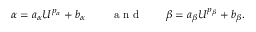Convert formula to latex. <formula><loc_0><loc_0><loc_500><loc_500>\alpha = a _ { \alpha } { U } ^ { p _ { \alpha } } + b _ { \alpha } \, \quad a n d \quad \beta = a _ { \beta } { U } ^ { p _ { \beta } } + b _ { \beta } .</formula> 